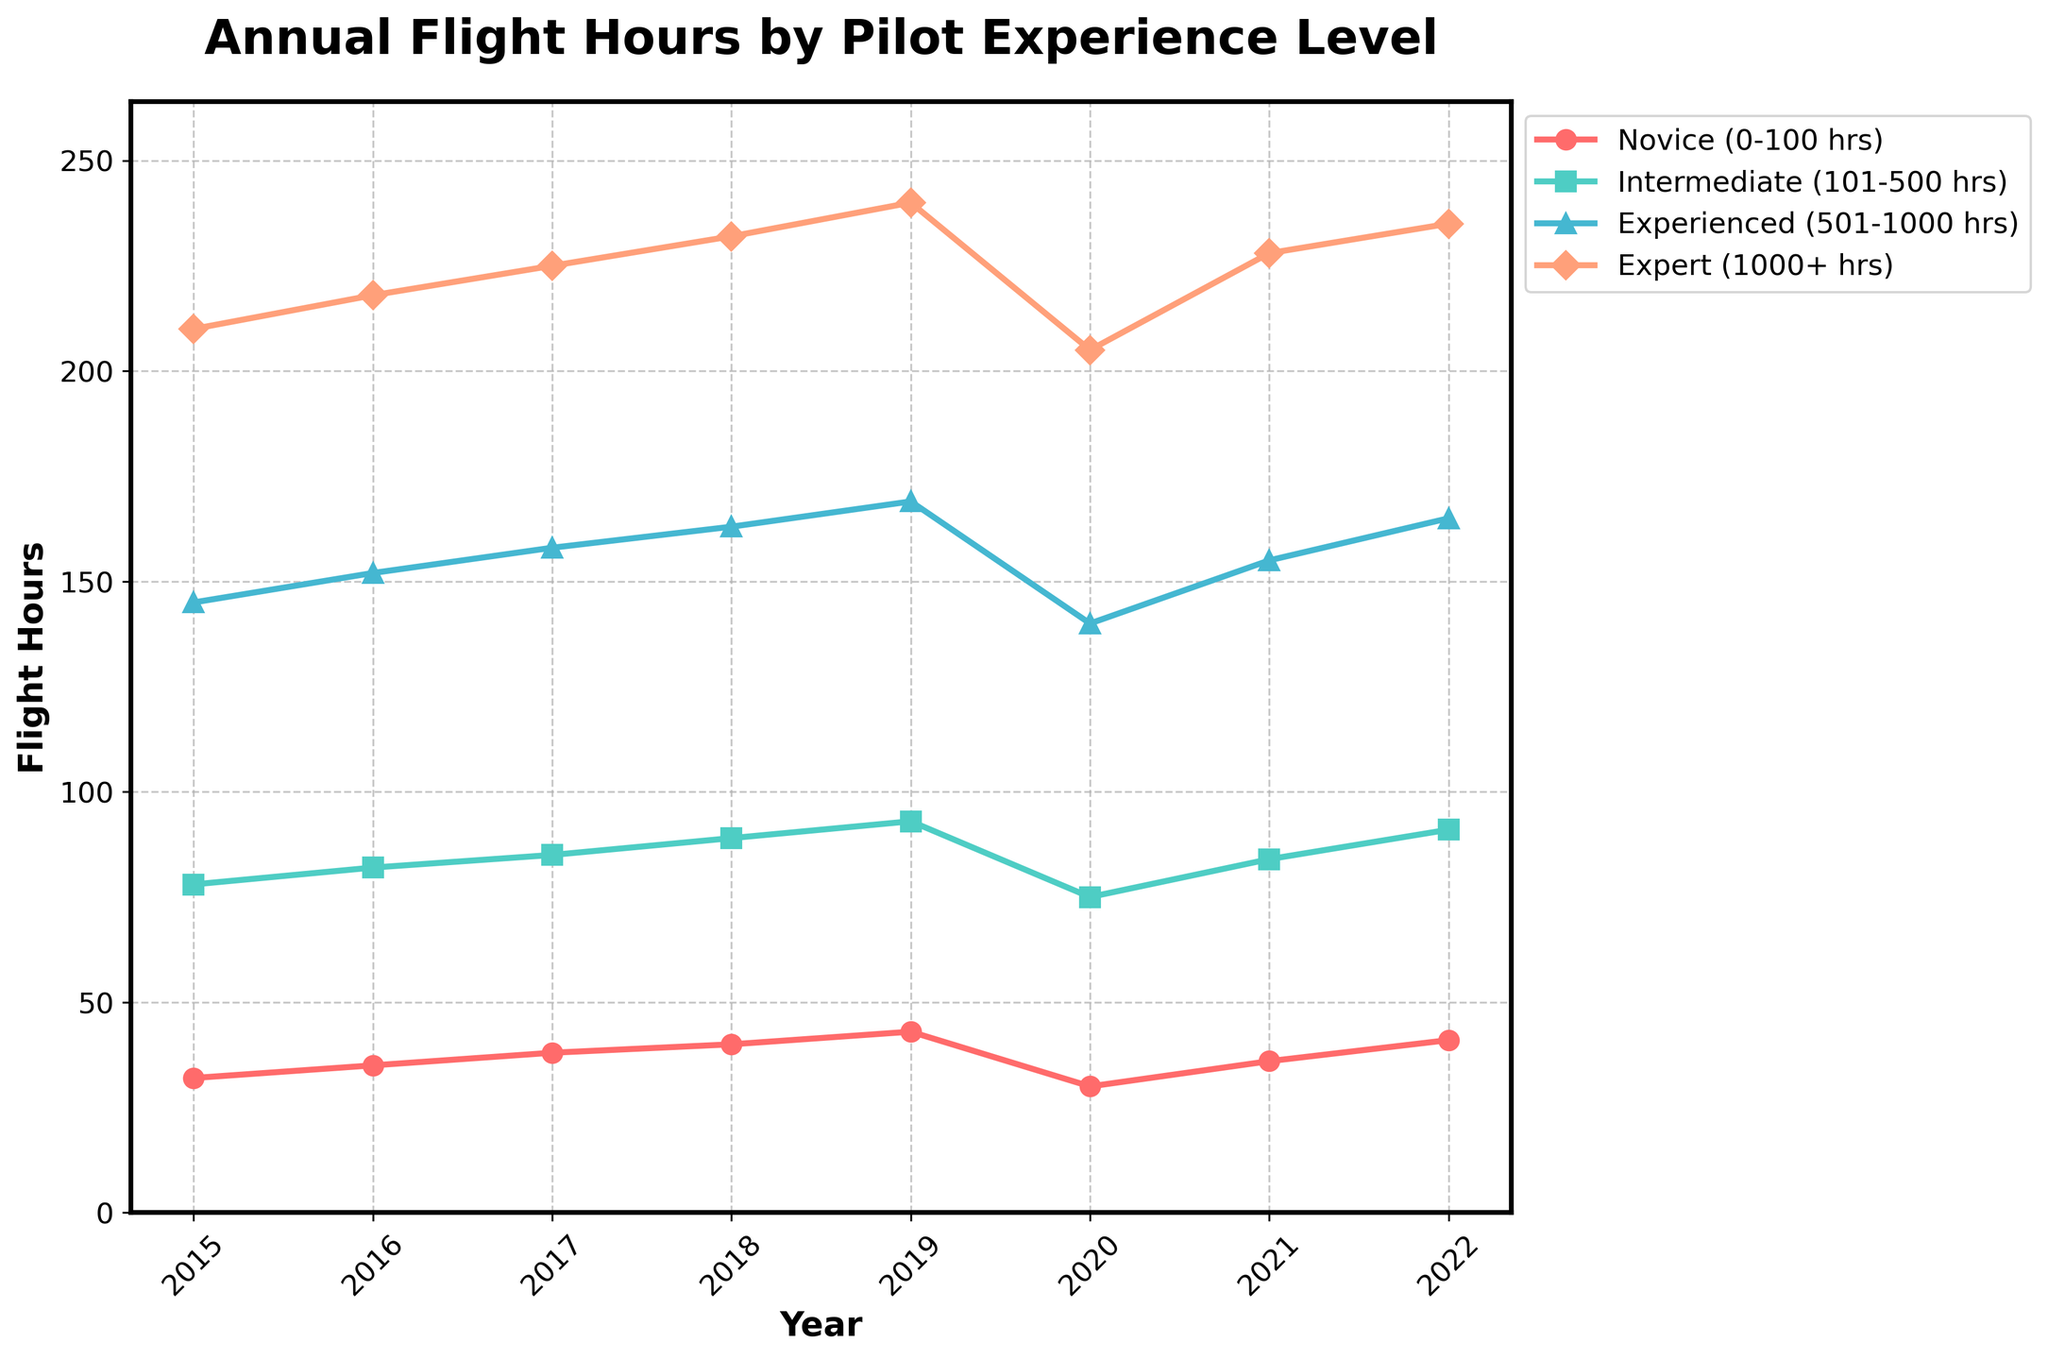What trend can be observed for the flight hours logged by novice pilots from 2015 to 2022? Observing the novice pilots' data points for the years 2015 to 2022, we see a general increasing trend, except for a dip in 2020.
Answer: Increasing, with a dip in 2020 How did the flight hours for intermediate pilots change from 2019 to 2020? From 2019, the flight hours for intermediate pilots dropped from 93 to 75 in 2020.
Answer: Decreased Which experience level shows the highest flight hours consistently from 2015 to 2022? By examining all data points across the years, expert pilots (1000+ hrs) consistently show the highest flight hours.
Answer: Expert pilots What is the total increase in flight hours for experienced pilots from 2015 to 2022? The experienced pilots' flight hours in 2015 were 145 and increased to 165 in 2022. The total increase is calculated as 165 - 145.
Answer: 20 hours Compare the flight hours for novices and experts in 2022. Which has a bigger difference? The novices logged 41 hours, while experts logged 235 hours in 2022. The difference is 235 - 41.
Answer: Experts with 194 hours difference In terms of flight hours, which year shows the lowest performance for all experience levels? By visually inspecting the plot, the year 2020 shows the lowest values across all experience levels.
Answer: 2020 What is the ratio of flight hours logged by novice pilots to expert pilots in 2020? Novice pilots logged 30 hours, and expert pilots logged 205 hours in 2020. The ratio is 30 / 205.
Answer: 0.15 What is the average annual flight hours logged by intermediate pilots from 2015 to 2022? Summing the annual flight hours for intermediate pilots: 78 + 82 + 85 + 89 + 93 + 75 + 84 + 91 = 677. The average is 677 / 8.
Answer: 84.625 hours 